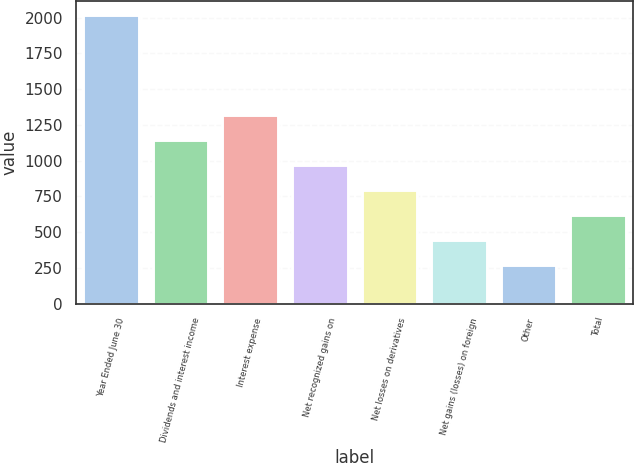Convert chart to OTSL. <chart><loc_0><loc_0><loc_500><loc_500><bar_chart><fcel>Year Ended June 30<fcel>Dividends and interest income<fcel>Interest expense<fcel>Net recognized gains on<fcel>Net losses on derivatives<fcel>Net gains (losses) on foreign<fcel>Other<fcel>Total<nl><fcel>2015<fcel>1141<fcel>1315.8<fcel>966.2<fcel>791.4<fcel>441.8<fcel>267<fcel>616.6<nl></chart> 